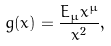Convert formula to latex. <formula><loc_0><loc_0><loc_500><loc_500>g ( x ) = \frac { E _ { \mu } x ^ { \mu } } { x ^ { 2 } } ,</formula> 